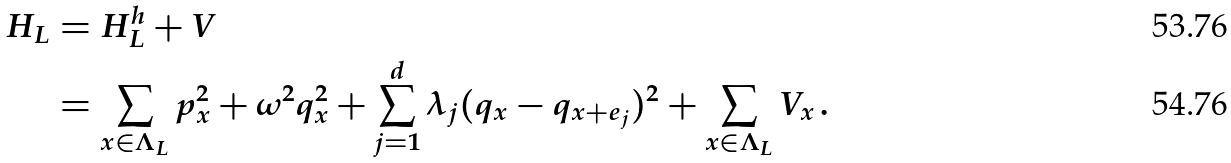Convert formula to latex. <formula><loc_0><loc_0><loc_500><loc_500>H _ { L } & = H _ { L } ^ { h } + V \\ & = \sum _ { x \in \Lambda _ { L } } p _ { x } ^ { 2 } + \omega ^ { 2 } q _ { x } ^ { 2 } + \sum _ { j = 1 } ^ { d } \lambda _ { j } ( q _ { x } - q _ { x + e _ { j } } ) ^ { 2 } + \sum _ { x \in \Lambda _ { L } } V _ { x } \, .</formula> 